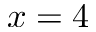<formula> <loc_0><loc_0><loc_500><loc_500>x = 4</formula> 